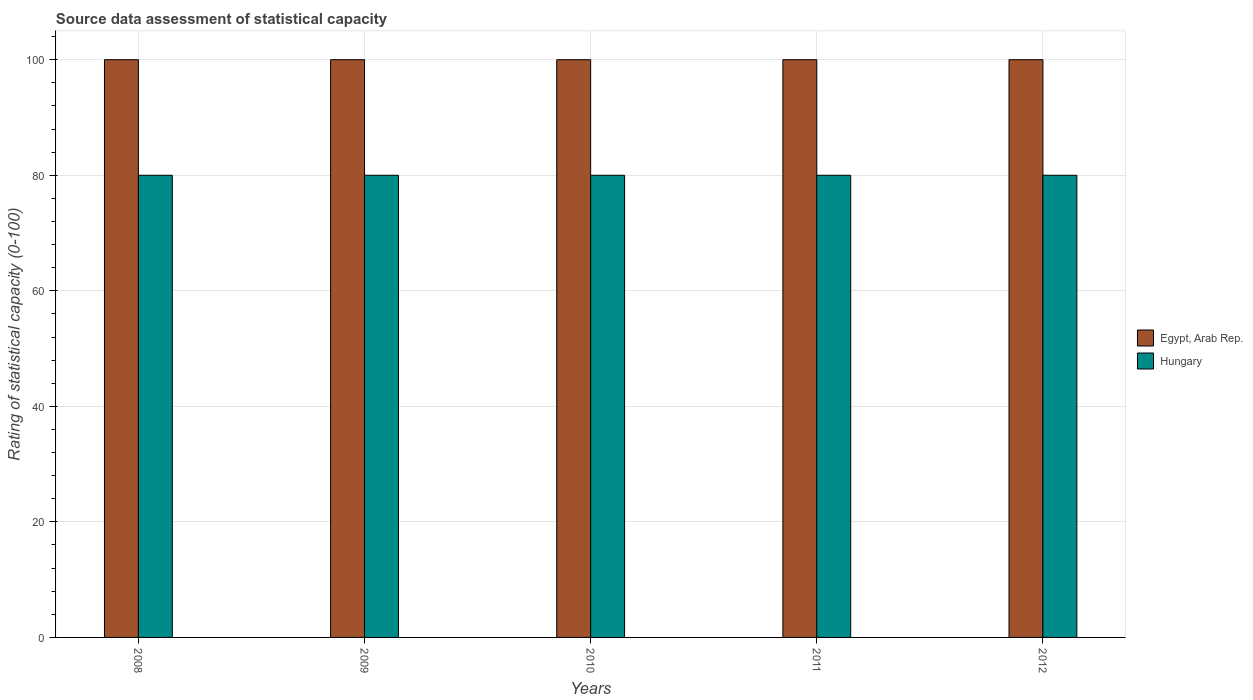Are the number of bars per tick equal to the number of legend labels?
Keep it short and to the point. Yes. Are the number of bars on each tick of the X-axis equal?
Your answer should be very brief. Yes. What is the label of the 3rd group of bars from the left?
Provide a short and direct response. 2010. In how many cases, is the number of bars for a given year not equal to the number of legend labels?
Offer a terse response. 0. What is the rating of statistical capacity in Hungary in 2010?
Give a very brief answer. 80. Across all years, what is the maximum rating of statistical capacity in Egypt, Arab Rep.?
Offer a very short reply. 100. Across all years, what is the minimum rating of statistical capacity in Hungary?
Your answer should be very brief. 80. In which year was the rating of statistical capacity in Hungary minimum?
Your answer should be compact. 2008. What is the total rating of statistical capacity in Hungary in the graph?
Ensure brevity in your answer.  400. What is the difference between the rating of statistical capacity in Egypt, Arab Rep. in 2008 and that in 2009?
Provide a short and direct response. 0. What is the difference between the rating of statistical capacity in Egypt, Arab Rep. in 2010 and the rating of statistical capacity in Hungary in 2009?
Give a very brief answer. 20. In the year 2010, what is the difference between the rating of statistical capacity in Hungary and rating of statistical capacity in Egypt, Arab Rep.?
Your answer should be very brief. -20. In how many years, is the rating of statistical capacity in Hungary greater than 76?
Offer a very short reply. 5. Is the rating of statistical capacity in Hungary in 2008 less than that in 2011?
Offer a terse response. No. Is the difference between the rating of statistical capacity in Hungary in 2009 and 2012 greater than the difference between the rating of statistical capacity in Egypt, Arab Rep. in 2009 and 2012?
Provide a short and direct response. No. What is the difference between the highest and the second highest rating of statistical capacity in Hungary?
Your answer should be very brief. 0. What does the 1st bar from the left in 2011 represents?
Provide a short and direct response. Egypt, Arab Rep. What does the 1st bar from the right in 2008 represents?
Your response must be concise. Hungary. Are all the bars in the graph horizontal?
Offer a terse response. No. How many years are there in the graph?
Provide a succinct answer. 5. Does the graph contain any zero values?
Your answer should be compact. No. How many legend labels are there?
Make the answer very short. 2. What is the title of the graph?
Make the answer very short. Source data assessment of statistical capacity. Does "Honduras" appear as one of the legend labels in the graph?
Make the answer very short. No. What is the label or title of the X-axis?
Offer a very short reply. Years. What is the label or title of the Y-axis?
Keep it short and to the point. Rating of statistical capacity (0-100). What is the Rating of statistical capacity (0-100) in Hungary in 2009?
Your response must be concise. 80. What is the Rating of statistical capacity (0-100) of Egypt, Arab Rep. in 2010?
Make the answer very short. 100. What is the Rating of statistical capacity (0-100) in Hungary in 2011?
Keep it short and to the point. 80. Across all years, what is the maximum Rating of statistical capacity (0-100) in Hungary?
Your answer should be very brief. 80. What is the difference between the Rating of statistical capacity (0-100) in Egypt, Arab Rep. in 2008 and that in 2010?
Give a very brief answer. 0. What is the difference between the Rating of statistical capacity (0-100) in Hungary in 2008 and that in 2011?
Provide a short and direct response. 0. What is the difference between the Rating of statistical capacity (0-100) in Egypt, Arab Rep. in 2008 and that in 2012?
Keep it short and to the point. 0. What is the difference between the Rating of statistical capacity (0-100) of Hungary in 2008 and that in 2012?
Give a very brief answer. 0. What is the difference between the Rating of statistical capacity (0-100) in Egypt, Arab Rep. in 2009 and that in 2010?
Offer a terse response. 0. What is the difference between the Rating of statistical capacity (0-100) of Egypt, Arab Rep. in 2009 and that in 2012?
Give a very brief answer. 0. What is the difference between the Rating of statistical capacity (0-100) in Hungary in 2009 and that in 2012?
Offer a very short reply. 0. What is the difference between the Rating of statistical capacity (0-100) of Hungary in 2010 and that in 2011?
Your answer should be very brief. 0. What is the difference between the Rating of statistical capacity (0-100) in Egypt, Arab Rep. in 2010 and that in 2012?
Make the answer very short. 0. What is the difference between the Rating of statistical capacity (0-100) in Hungary in 2010 and that in 2012?
Ensure brevity in your answer.  0. What is the difference between the Rating of statistical capacity (0-100) in Hungary in 2011 and that in 2012?
Keep it short and to the point. 0. What is the difference between the Rating of statistical capacity (0-100) of Egypt, Arab Rep. in 2008 and the Rating of statistical capacity (0-100) of Hungary in 2009?
Your response must be concise. 20. What is the difference between the Rating of statistical capacity (0-100) in Egypt, Arab Rep. in 2008 and the Rating of statistical capacity (0-100) in Hungary in 2010?
Provide a short and direct response. 20. What is the difference between the Rating of statistical capacity (0-100) in Egypt, Arab Rep. in 2008 and the Rating of statistical capacity (0-100) in Hungary in 2011?
Your answer should be very brief. 20. What is the difference between the Rating of statistical capacity (0-100) in Egypt, Arab Rep. in 2008 and the Rating of statistical capacity (0-100) in Hungary in 2012?
Your response must be concise. 20. What is the difference between the Rating of statistical capacity (0-100) in Egypt, Arab Rep. in 2010 and the Rating of statistical capacity (0-100) in Hungary in 2011?
Give a very brief answer. 20. What is the difference between the Rating of statistical capacity (0-100) in Egypt, Arab Rep. in 2010 and the Rating of statistical capacity (0-100) in Hungary in 2012?
Provide a short and direct response. 20. What is the difference between the Rating of statistical capacity (0-100) in Egypt, Arab Rep. in 2011 and the Rating of statistical capacity (0-100) in Hungary in 2012?
Provide a short and direct response. 20. In the year 2010, what is the difference between the Rating of statistical capacity (0-100) of Egypt, Arab Rep. and Rating of statistical capacity (0-100) of Hungary?
Make the answer very short. 20. What is the ratio of the Rating of statistical capacity (0-100) in Hungary in 2008 to that in 2010?
Your answer should be very brief. 1. What is the ratio of the Rating of statistical capacity (0-100) in Hungary in 2008 to that in 2012?
Provide a short and direct response. 1. What is the ratio of the Rating of statistical capacity (0-100) in Egypt, Arab Rep. in 2009 to that in 2010?
Give a very brief answer. 1. What is the ratio of the Rating of statistical capacity (0-100) of Hungary in 2009 to that in 2011?
Offer a terse response. 1. What is the ratio of the Rating of statistical capacity (0-100) in Hungary in 2009 to that in 2012?
Your response must be concise. 1. What is the ratio of the Rating of statistical capacity (0-100) in Hungary in 2010 to that in 2011?
Make the answer very short. 1. What is the ratio of the Rating of statistical capacity (0-100) in Egypt, Arab Rep. in 2010 to that in 2012?
Offer a terse response. 1. What is the ratio of the Rating of statistical capacity (0-100) of Egypt, Arab Rep. in 2011 to that in 2012?
Your answer should be compact. 1. What is the ratio of the Rating of statistical capacity (0-100) in Hungary in 2011 to that in 2012?
Provide a succinct answer. 1. What is the difference between the highest and the second highest Rating of statistical capacity (0-100) of Hungary?
Keep it short and to the point. 0. What is the difference between the highest and the lowest Rating of statistical capacity (0-100) in Egypt, Arab Rep.?
Offer a very short reply. 0. What is the difference between the highest and the lowest Rating of statistical capacity (0-100) of Hungary?
Give a very brief answer. 0. 